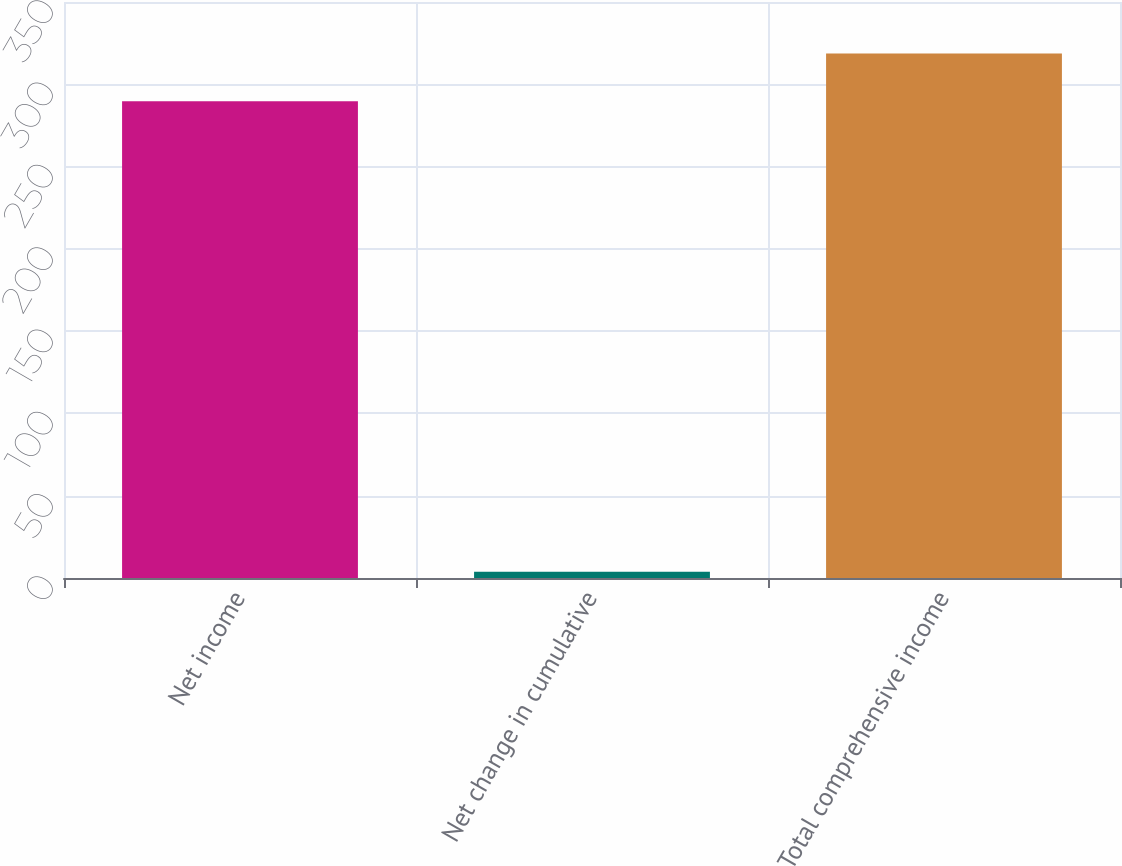Convert chart. <chart><loc_0><loc_0><loc_500><loc_500><bar_chart><fcel>Net income<fcel>Net change in cumulative<fcel>Total comprehensive income<nl><fcel>289.7<fcel>3.8<fcel>318.67<nl></chart> 